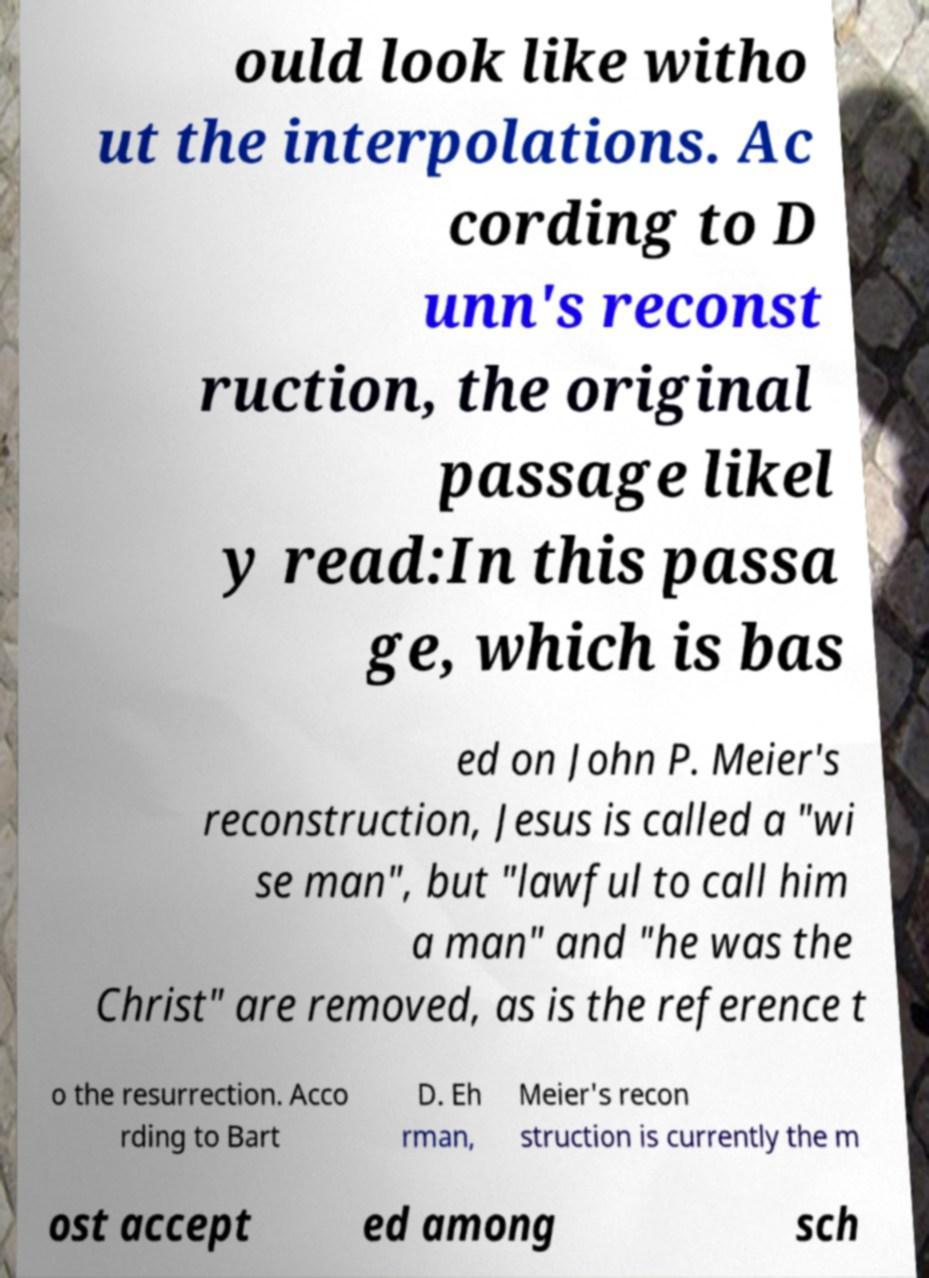There's text embedded in this image that I need extracted. Can you transcribe it verbatim? ould look like witho ut the interpolations. Ac cording to D unn's reconst ruction, the original passage likel y read:In this passa ge, which is bas ed on John P. Meier's reconstruction, Jesus is called a "wi se man", but "lawful to call him a man" and "he was the Christ" are removed, as is the reference t o the resurrection. Acco rding to Bart D. Eh rman, Meier's recon struction is currently the m ost accept ed among sch 